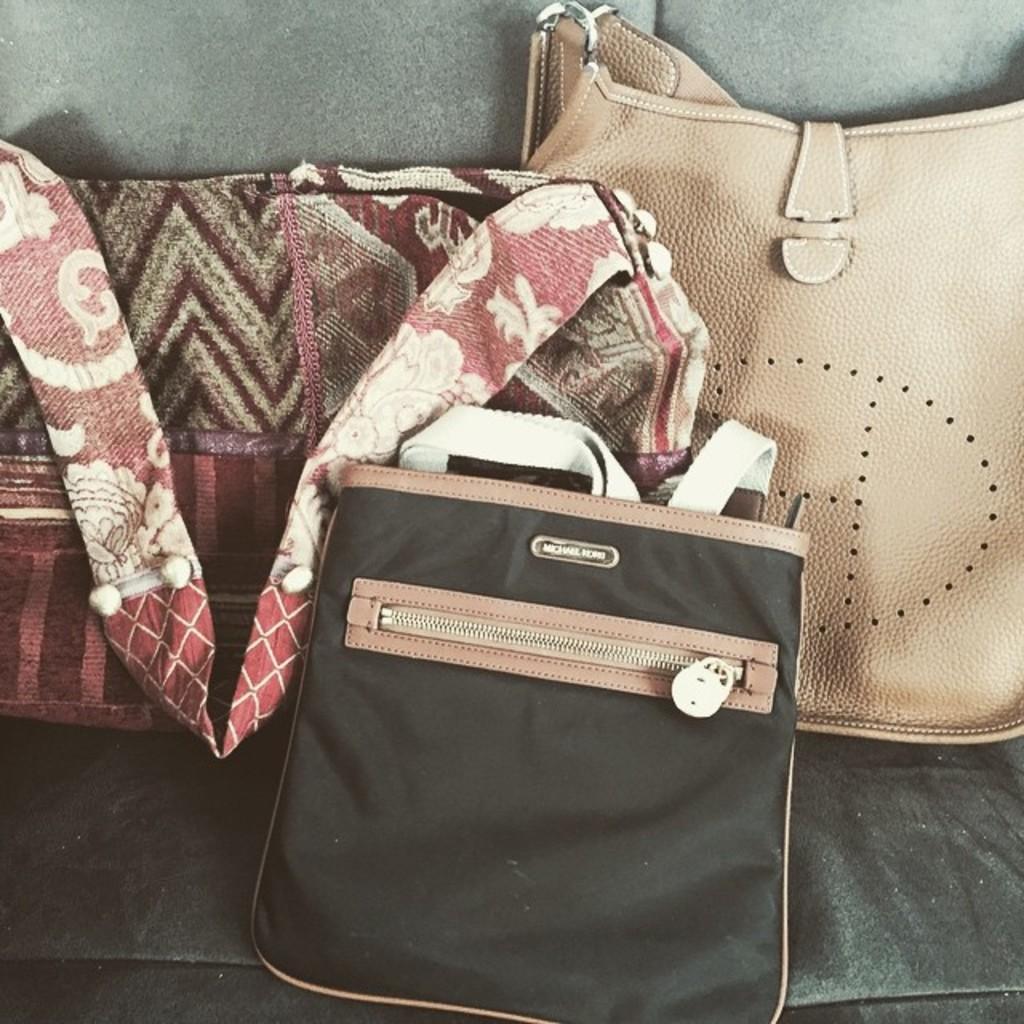Please provide a concise description of this image. There are three hand bags of different types are placed on a sofa. 